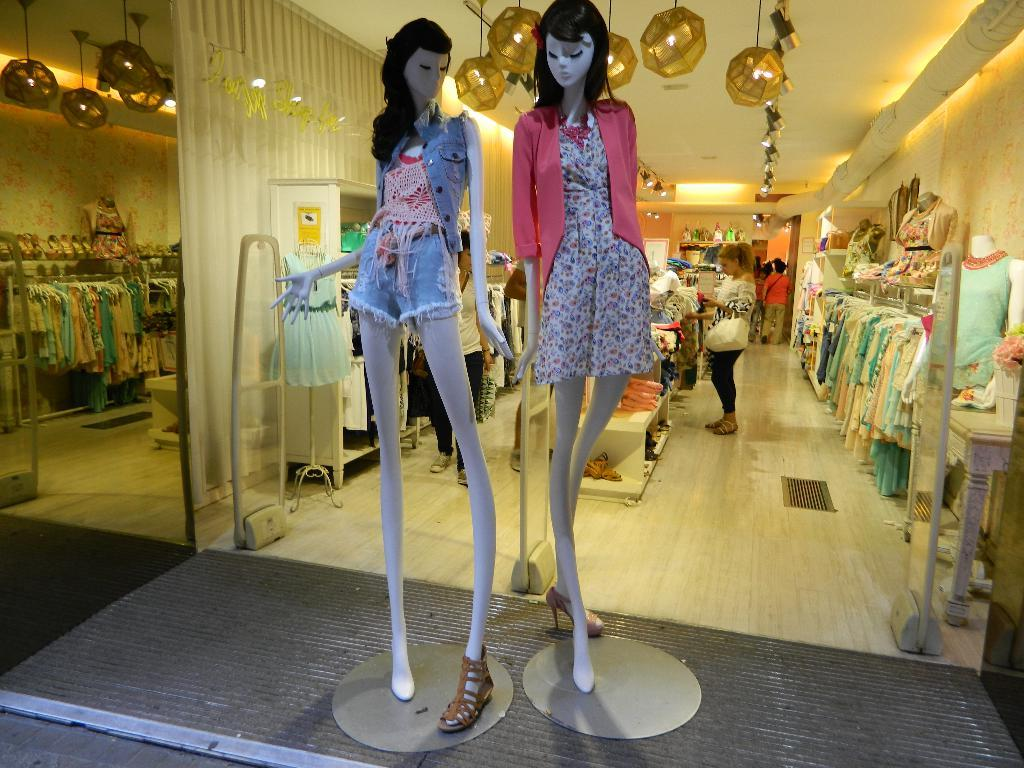What type of figures are present in the image? There are mannequins in the image. What are the mannequins wearing? The mannequins have clothes on them. Can you describe the setting in the background of the image? There are people, clothes, lights on the ceiling, walls, and other objects visible in the background of the image. How many fairies are visible in the image? There are no fairies present in the image. What type of vest is being worn by the mannequins in the image? The mannequins in the image are not wearing vests; they are wearing clothes, but no specific type of clothing is mentioned in the facts provided. 